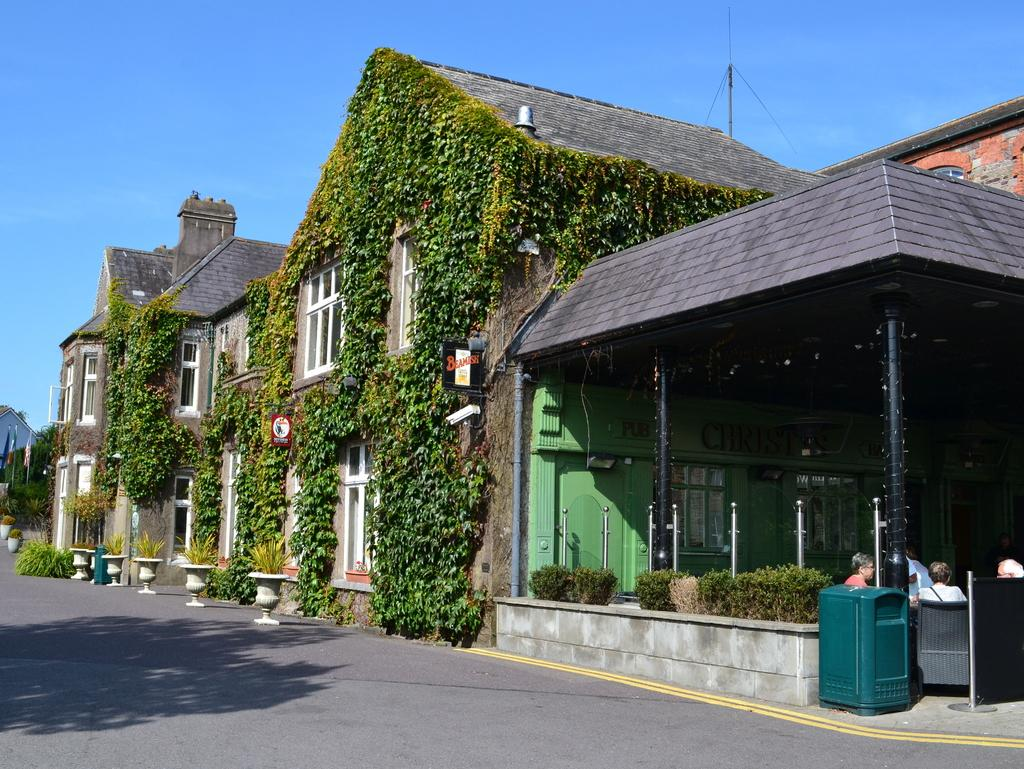What is the main feature of the image? There is a road in the image. What else can be seen along the road? There are pots, poles, plants, flags, and some people sitting on chairs. Can you describe the buildings in the image? The buildings have windows. What is visible in the background of the image? The sky is visible in the background of the image. What direction is the twig pointing towards in the image? There is no twig present in the image. What is the color of the sky in the north part of the image? The image does not specify a direction, and the color of the sky is visible throughout the background. 